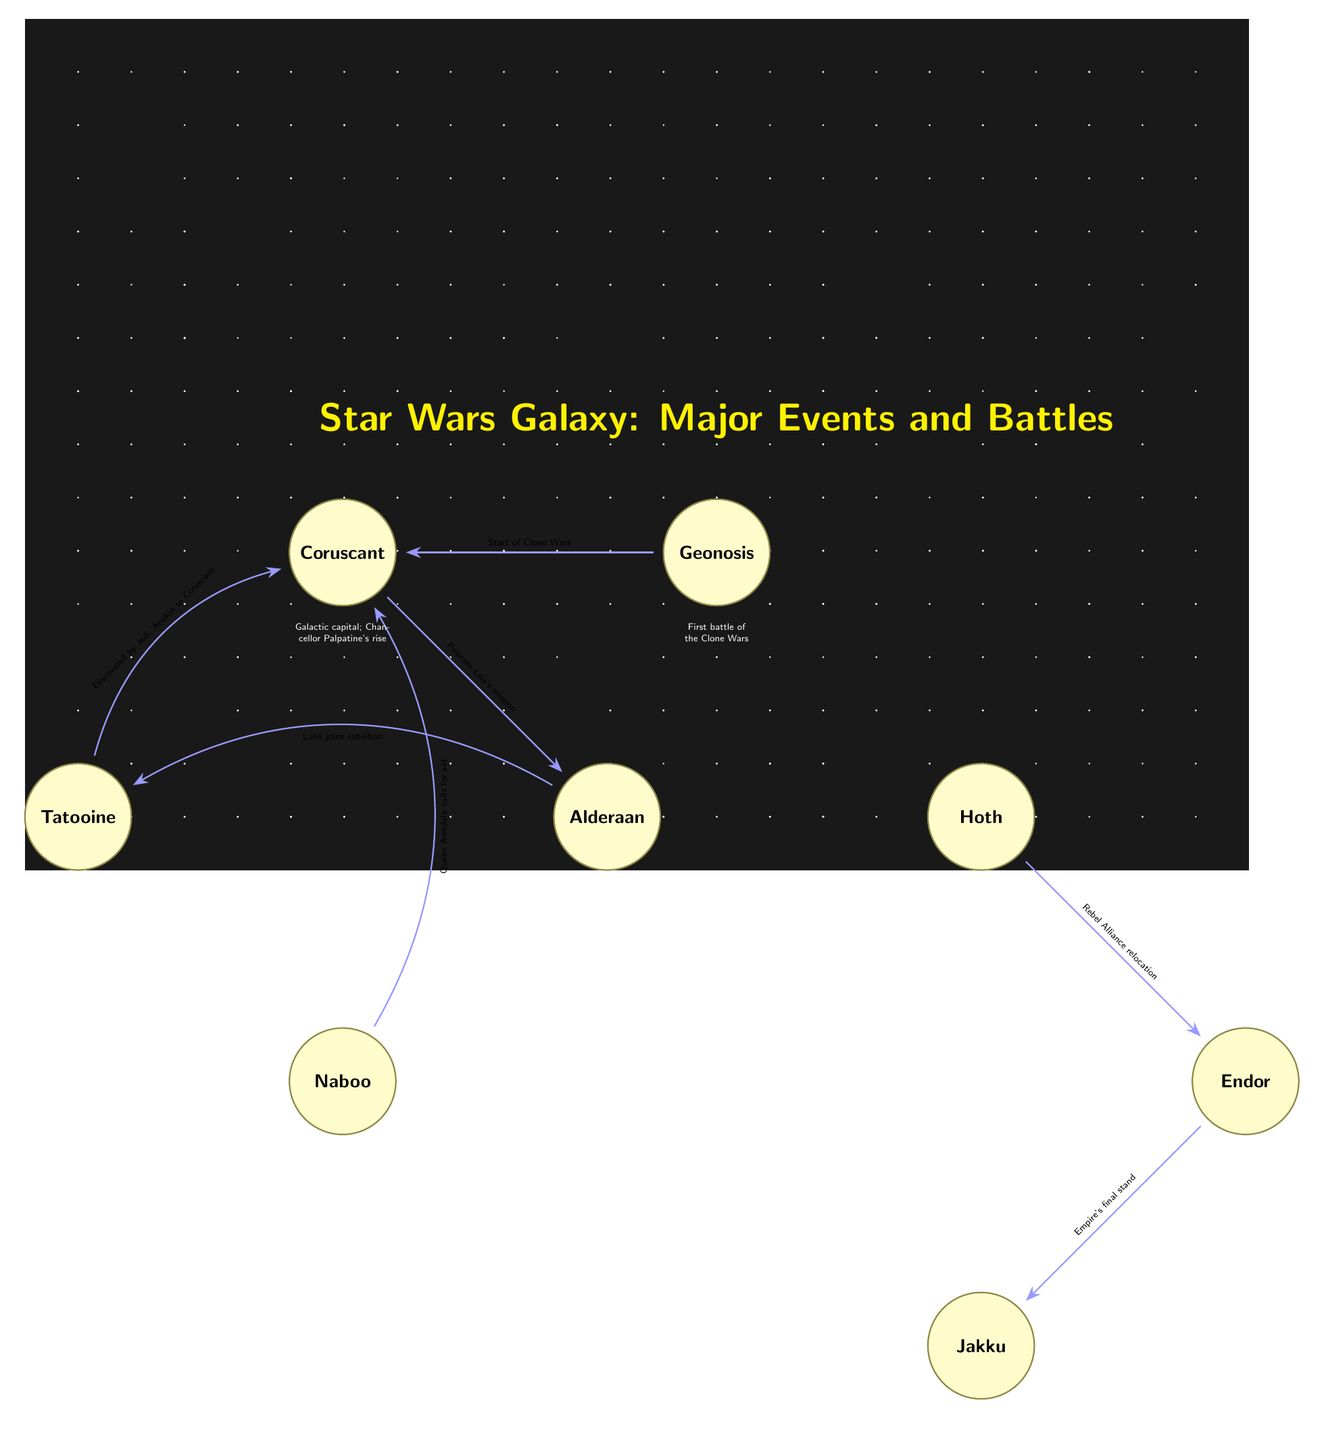What planet is Anakin Skywalker’s home? The diagram specifically identifies Tatooine as Anakin Skywalker’s home planet. This is further confirmed by the description beneath the Tatooine node.
Answer: Tatooine Which planet experienced a battle as a result of Queen Amidala calling for aid? The connection from the Naboo node to Coruscant indicates that Queen Amidala called for aid, and this is inferred within the context of the battle associated with Naboo. Therefore, Naboo is the answer.
Answer: Naboo What major event is depicted between Coruscant and Geonosis? The connection between these two nodes clearly states "Start of Clone Wars." This indicates that this was a significant event in the timeline of the diagram.
Answer: Start of Clone Wars How many total planets are depicted in the diagram? By counting the planets listed in the diagram (Tatooine, Coruscant, Naboo, Geonosis, Alderaan, Hoth, Endor, Jakku), there are eight planets total.
Answer: 8 What is the relationship between Alderaan and Tatooine? The arrow directed from Alderaan to Tatooine indicates that Luke joins the rebellion, which involves Tatooine as a significant point. This establishes the connection based on the shared context of the rebellion.
Answer: Luke joins rebellion What event took place at the planet Hoth? The description under the Hoth node explicitly states that it was a Rebel Alliance base and identifies the "Battle of Hoth" as a significant event related to Hoth.
Answer: Battle of Hoth Which planet is associated with the final stand of the Empire? The connection from Endor to Jakku specifies that "Empire's final stand" occurred at Jakku. This contextualizes Jakku as the location for this last major event.
Answer: Jakku In which part of the diagram does the first battle of the Clone Wars take place? The node for Geonosis is directly associated with the "First battle of the Clone Wars" as specified in the description beneath it, making Geonosis the answer.
Answer: Geonosis Which planet was destroyed by the Death Star? The description beneath the Alderaan node informs that Alderaan was destroyed by the Death Star, thus identifying it as the relevant planet.
Answer: Alderaan 